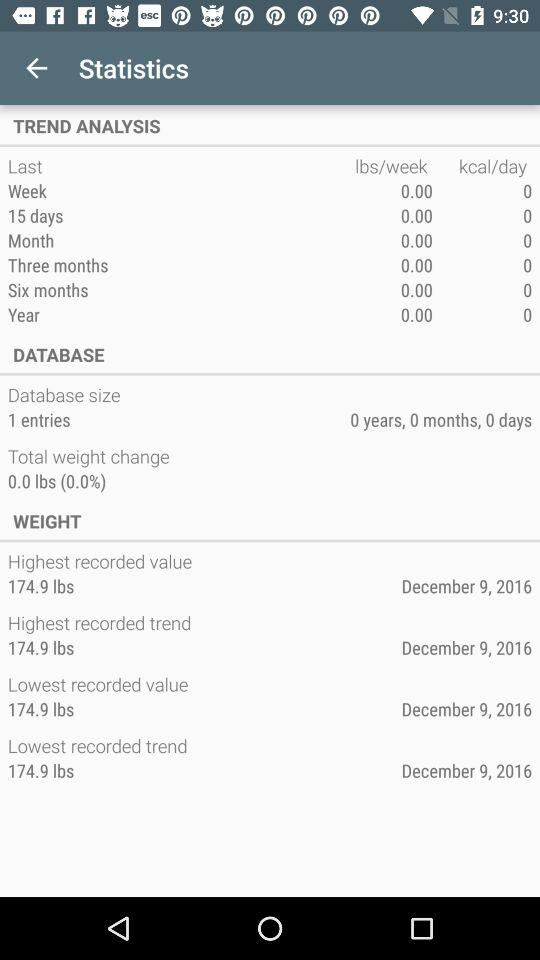What is the number of entries in the database size? The database currently contains one entry. This suggests it's at the very initial stage of data accumulation or usage. 